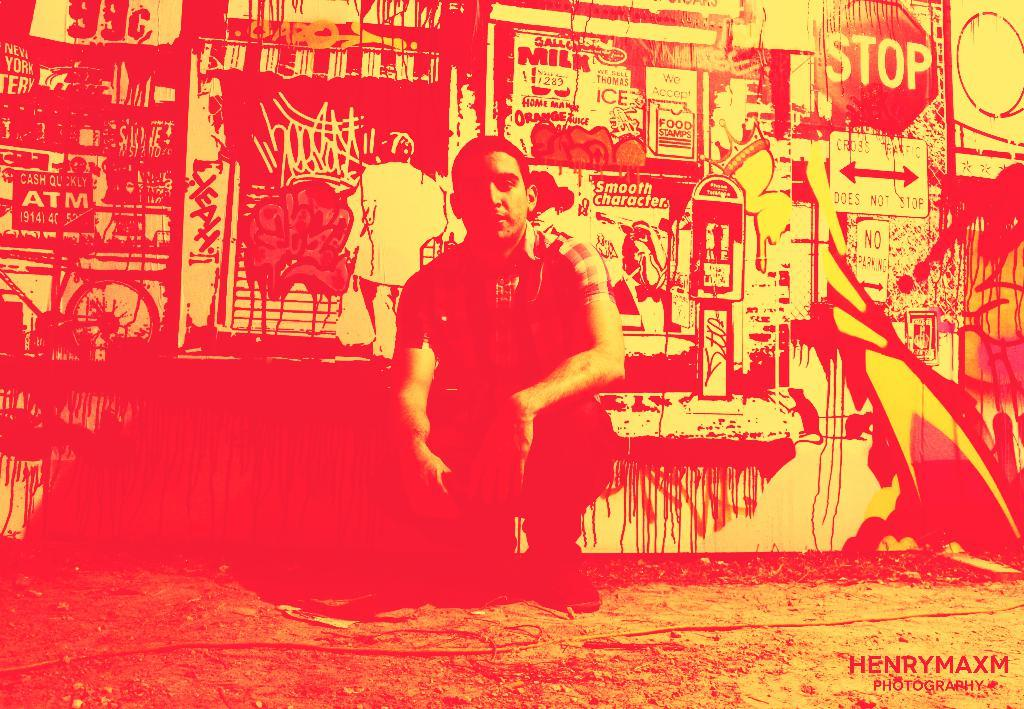<image>
Summarize the visual content of the image. A man sits in front of a wall cluttered with images, including the word Milk and a stop sign. 